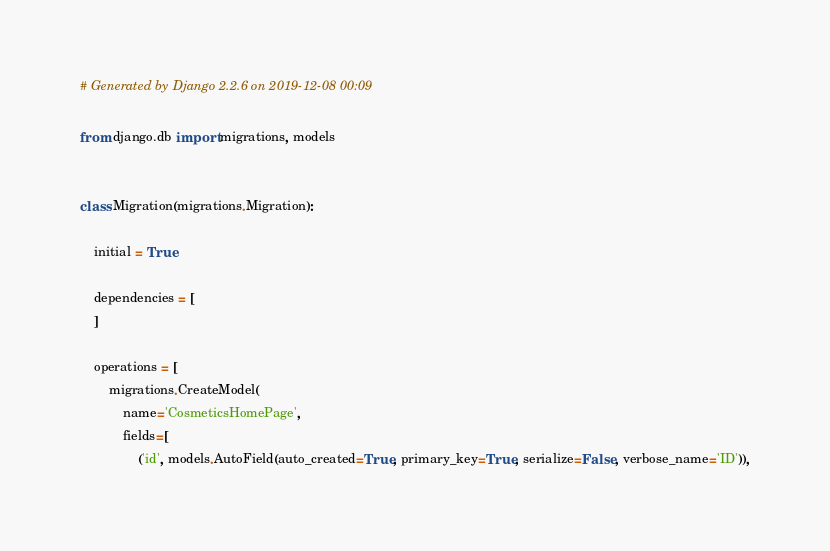Convert code to text. <code><loc_0><loc_0><loc_500><loc_500><_Python_># Generated by Django 2.2.6 on 2019-12-08 00:09

from django.db import migrations, models


class Migration(migrations.Migration):

    initial = True

    dependencies = [
    ]

    operations = [
        migrations.CreateModel(
            name='CosmeticsHomePage',
            fields=[
                ('id', models.AutoField(auto_created=True, primary_key=True, serialize=False, verbose_name='ID')),</code> 